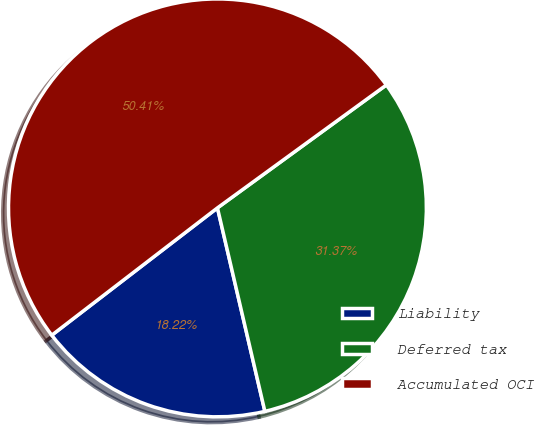Convert chart. <chart><loc_0><loc_0><loc_500><loc_500><pie_chart><fcel>Liability<fcel>Deferred tax<fcel>Accumulated OCI<nl><fcel>18.22%<fcel>31.37%<fcel>50.42%<nl></chart> 